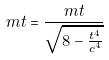Convert formula to latex. <formula><loc_0><loc_0><loc_500><loc_500>m t = \frac { m t } { \sqrt { 8 - \frac { t ^ { 4 } } { c ^ { 4 } } } }</formula> 